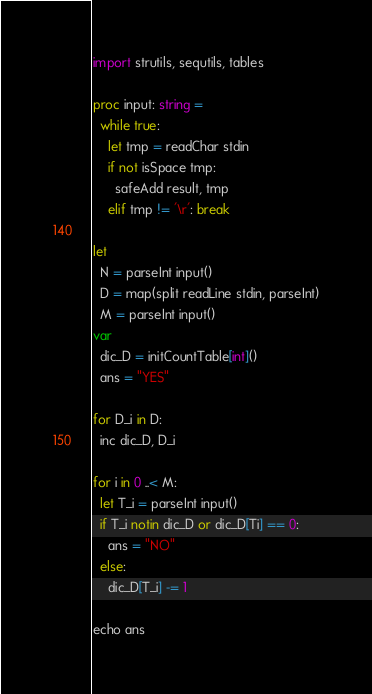<code> <loc_0><loc_0><loc_500><loc_500><_Nim_>import strutils, sequtils, tables

proc input: string =
  while true:
    let tmp = readChar stdin
    if not isSpace tmp:
      safeAdd result, tmp
    elif tmp != '\r': break

let
  N = parseInt input()
  D = map(split readLine stdin, parseInt)
  M = parseInt input()
var
  dic_D = initCountTable[int]()
  ans = "YES"

for D_i in D:
  inc dic_D, D_i

for i in 0 ..< M:
  let T_i = parseInt input()
  if T_i notin dic_D or dic_D[Ti] == 0:
    ans = "NO"
  else:
    dic_D[T_i] -= 1

echo ans
</code> 